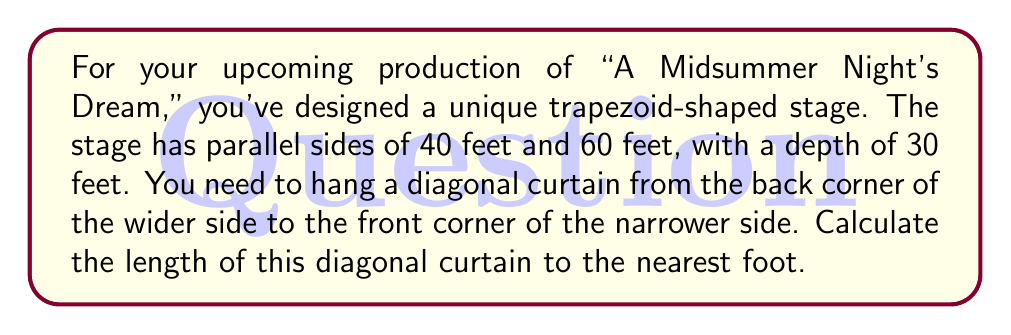Give your solution to this math problem. Let's approach this step-by-step:

1) First, we need to visualize the trapezoid stage:

[asy]
unitsize(4pt);
pair A = (0,0), B = (60,0), C = (50,30), D = (10,30);
draw(A--B--C--D--cycle);
draw(A--C,dashed);
label("60'", (30,0), S);
label("40'", (30,30), N);
label("30'", (0,15), W);
label("x", (25,15), SE);
[/asy]

2) The diagonal curtain forms the hypotenuse of a right triangle. We need to find the length of this hypotenuse.

3) We know the depth of the stage (30 feet), which is the height of this triangle.

4) To find the base of this triangle, we need to calculate the difference between the wider side and the narrower side, and divide by 2:

   $$(60 - 40) \div 2 = 10\text{ feet}$$

5) Now we have a right triangle with base 10 feet and height 30 feet. We can use the Pythagorean theorem to find the length of the hypotenuse (our diagonal curtain):

   $$x^2 = 10^2 + 30^2$$

6) Let's solve this equation:

   $$x^2 = 100 + 900 = 1000$$

7) Taking the square root of both sides:

   $$x = \sqrt{1000} \approx 31.62\text{ feet}$$

8) Rounding to the nearest foot:

   $$x \approx 32\text{ feet}$$

Therefore, the diagonal curtain should be approximately 32 feet long.
Answer: The length of the diagonal curtain should be 32 feet. 